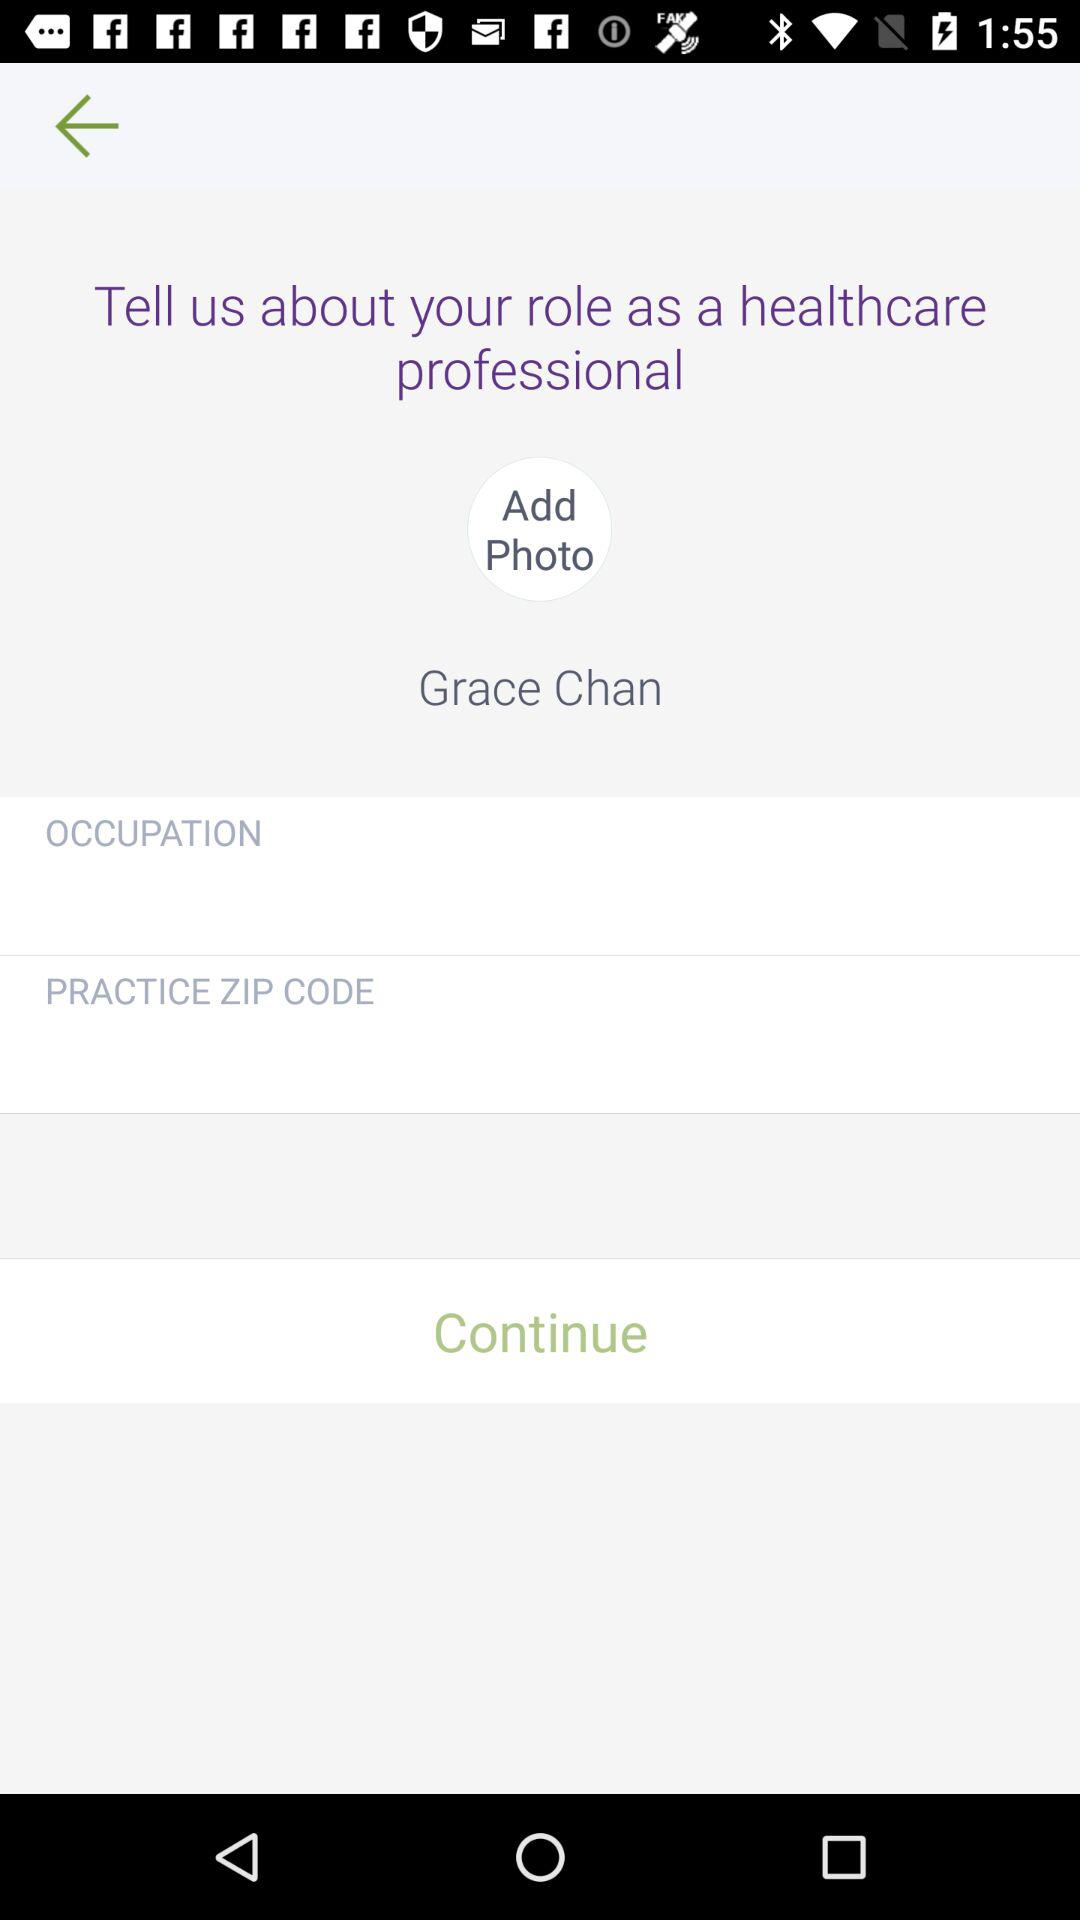How many text inputs are there that are not empty?
Answer the question using a single word or phrase. 2 